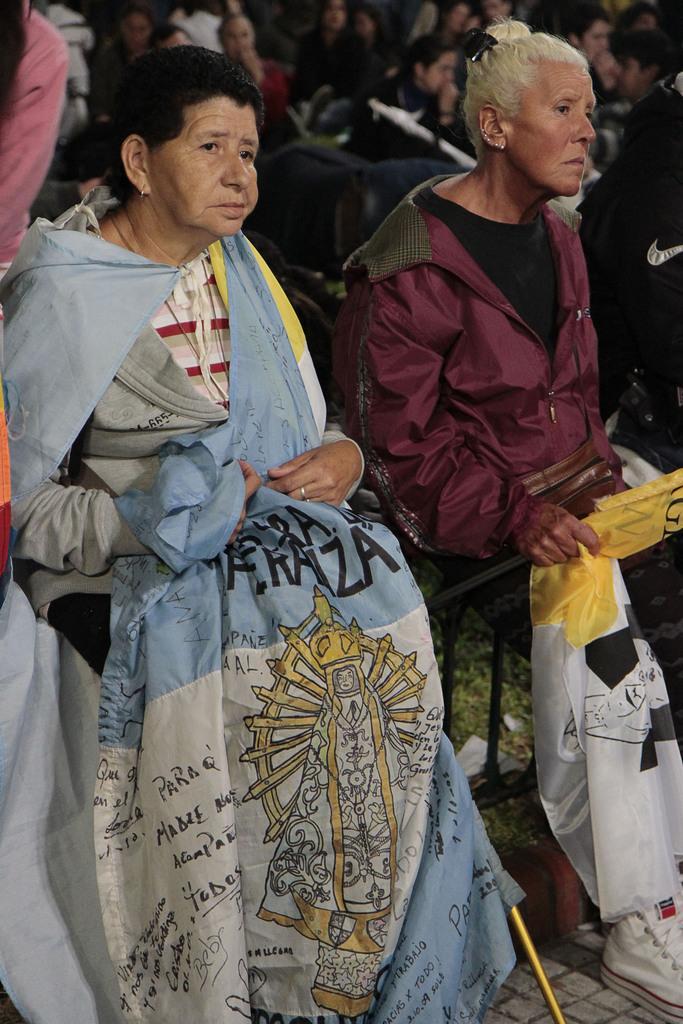How would you summarize this image in a sentence or two? In the foreground of this image, there is a woman holding a flag. Beside her, there is another woman sitting and holding a flag. In the background, there are few people. 